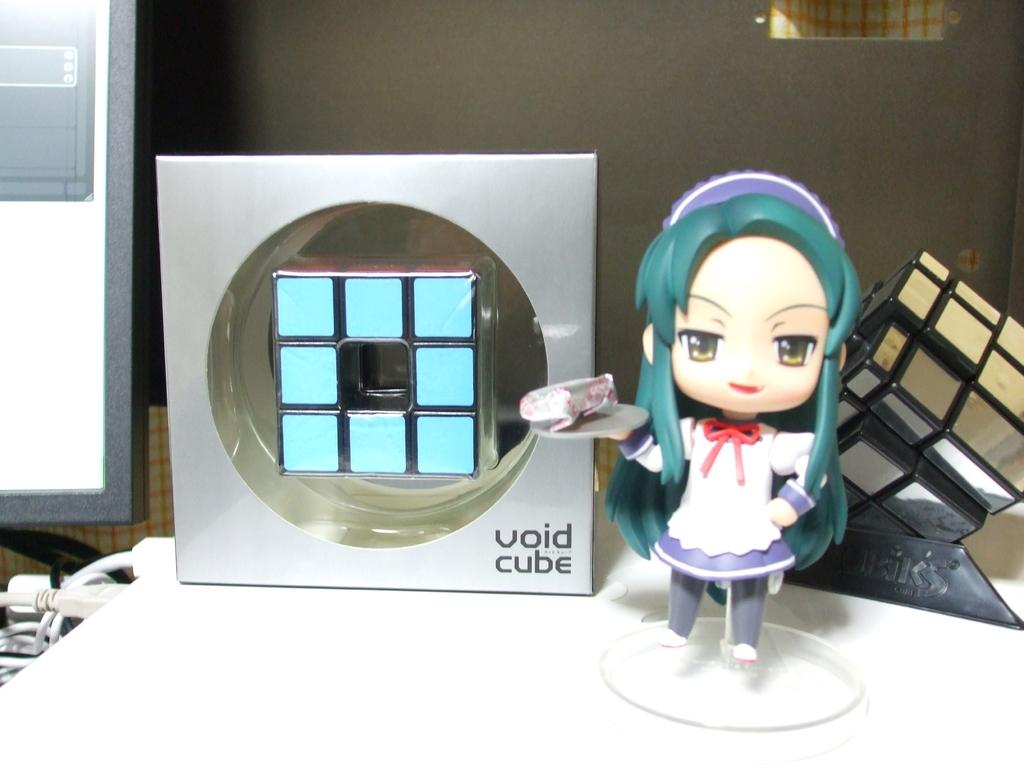What type of toy is present in the image? There is a toy in the image, but its specific type is not mentioned. How many Rubik's cubes are visible in the image? There are two Rubik's cubes in the image. Can you describe the surface on which the objects are placed? The objects are on an unspecified surface, so we cannot describe its material or appearance. What can be seen in the background of the image? In the background of the image, there are cables and a board. What type of garden can be seen in the image? There is no garden present in the image; it features a toy, Rubik's cubes, and a background with cables and a board. What type of bag is visible in the image? There is no bag present in the image. 